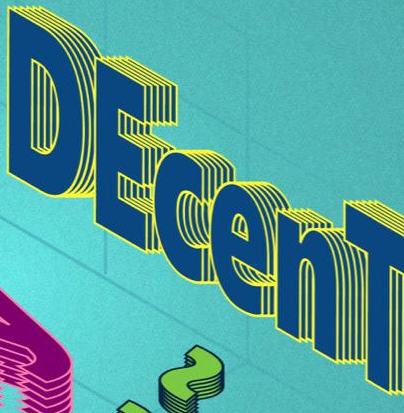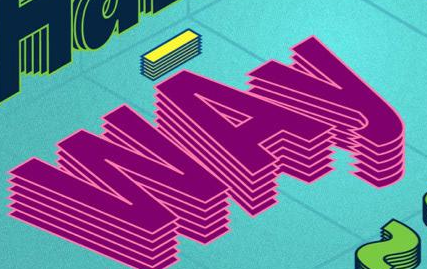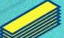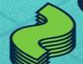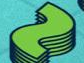What words can you see in these images in sequence, separated by a semicolon? DEcenT; WAy; -; ~; ~ 